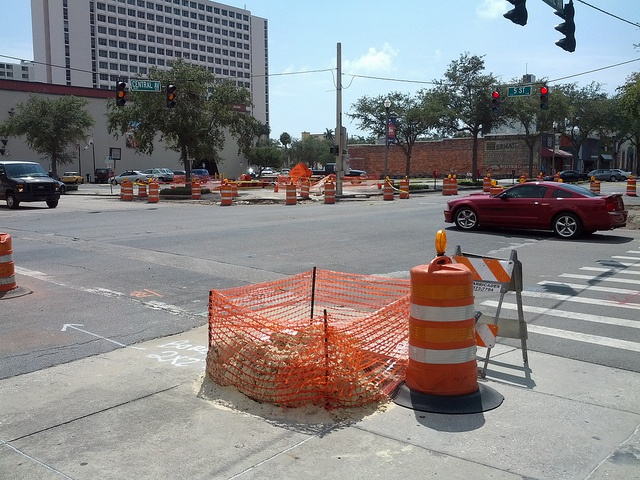Describe the objects in this image and their specific colors. I can see car in lightblue, black, maroon, gray, and darkgray tones, truck in lightblue, black, gray, darkblue, and blue tones, car in lightblue, black, gray, darkblue, and blue tones, traffic light in lightblue, black, and navy tones, and car in lightblue, gray, black, and darkgray tones in this image. 